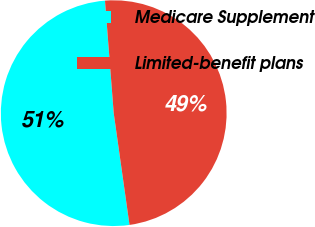<chart> <loc_0><loc_0><loc_500><loc_500><pie_chart><fcel>Medicare Supplement<fcel>Limited-benefit plans<nl><fcel>51.0%<fcel>49.0%<nl></chart> 